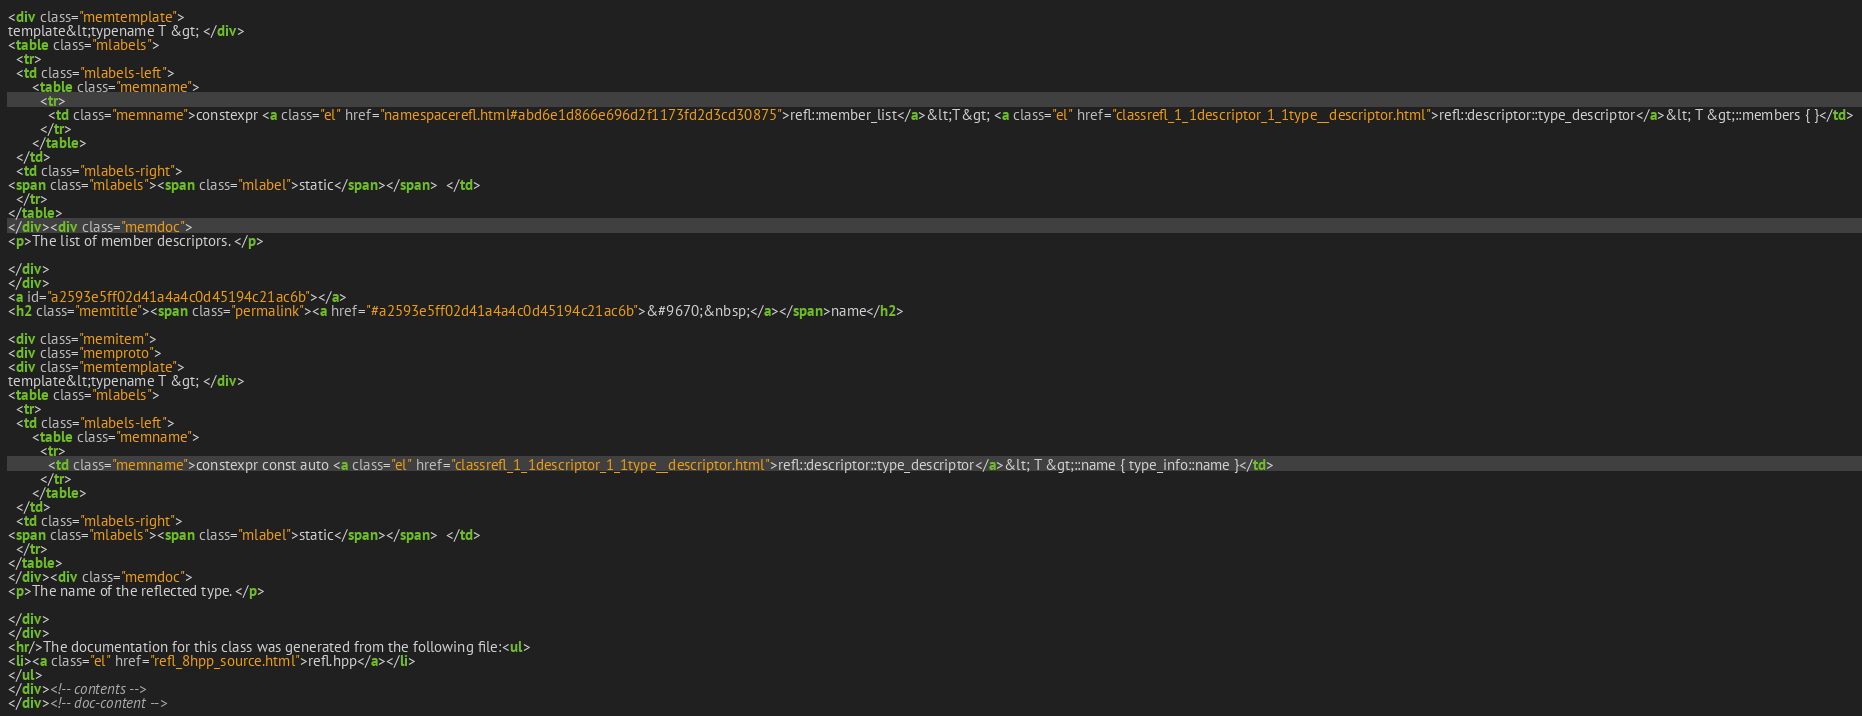Convert code to text. <code><loc_0><loc_0><loc_500><loc_500><_HTML_><div class="memtemplate">
template&lt;typename T &gt; </div>
<table class="mlabels">
  <tr>
  <td class="mlabels-left">
      <table class="memname">
        <tr>
          <td class="memname">constexpr <a class="el" href="namespacerefl.html#abd6e1d866e696d2f1173fd2d3cd30875">refl::member_list</a>&lt;T&gt; <a class="el" href="classrefl_1_1descriptor_1_1type__descriptor.html">refl::descriptor::type_descriptor</a>&lt; T &gt;::members { }</td>
        </tr>
      </table>
  </td>
  <td class="mlabels-right">
<span class="mlabels"><span class="mlabel">static</span></span>  </td>
  </tr>
</table>
</div><div class="memdoc">
<p>The list of member descriptors. </p>

</div>
</div>
<a id="a2593e5ff02d41a4a4c0d45194c21ac6b"></a>
<h2 class="memtitle"><span class="permalink"><a href="#a2593e5ff02d41a4a4c0d45194c21ac6b">&#9670;&nbsp;</a></span>name</h2>

<div class="memitem">
<div class="memproto">
<div class="memtemplate">
template&lt;typename T &gt; </div>
<table class="mlabels">
  <tr>
  <td class="mlabels-left">
      <table class="memname">
        <tr>
          <td class="memname">constexpr const auto <a class="el" href="classrefl_1_1descriptor_1_1type__descriptor.html">refl::descriptor::type_descriptor</a>&lt; T &gt;::name { type_info::name }</td>
        </tr>
      </table>
  </td>
  <td class="mlabels-right">
<span class="mlabels"><span class="mlabel">static</span></span>  </td>
  </tr>
</table>
</div><div class="memdoc">
<p>The name of the reflected type. </p>

</div>
</div>
<hr/>The documentation for this class was generated from the following file:<ul>
<li><a class="el" href="refl_8hpp_source.html">refl.hpp</a></li>
</ul>
</div><!-- contents -->
</div><!-- doc-content --></code> 